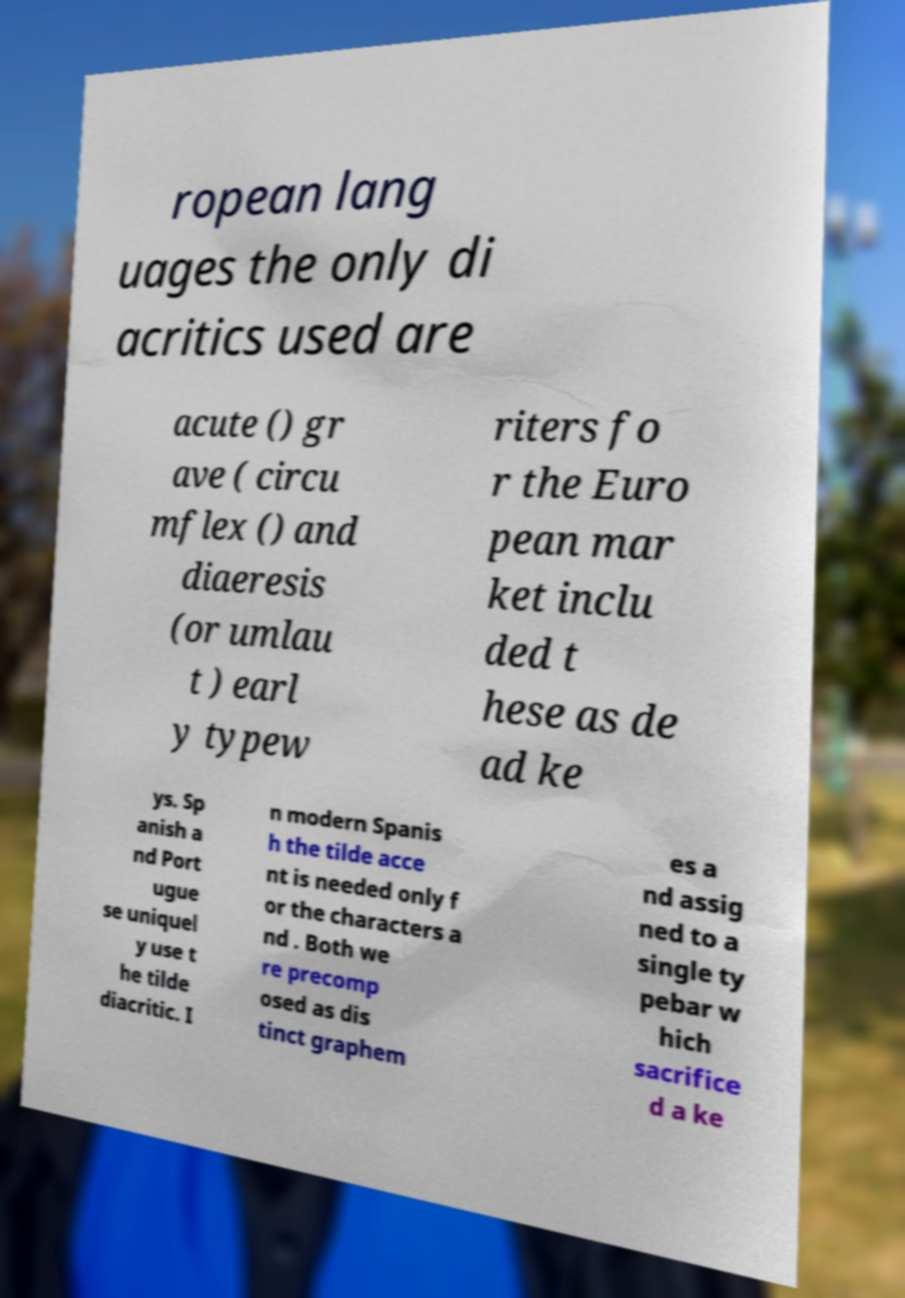Can you read and provide the text displayed in the image?This photo seems to have some interesting text. Can you extract and type it out for me? ropean lang uages the only di acritics used are acute () gr ave ( circu mflex () and diaeresis (or umlau t ) earl y typew riters fo r the Euro pean mar ket inclu ded t hese as de ad ke ys. Sp anish a nd Port ugue se uniquel y use t he tilde diacritic. I n modern Spanis h the tilde acce nt is needed only f or the characters a nd . Both we re precomp osed as dis tinct graphem es a nd assig ned to a single ty pebar w hich sacrifice d a ke 